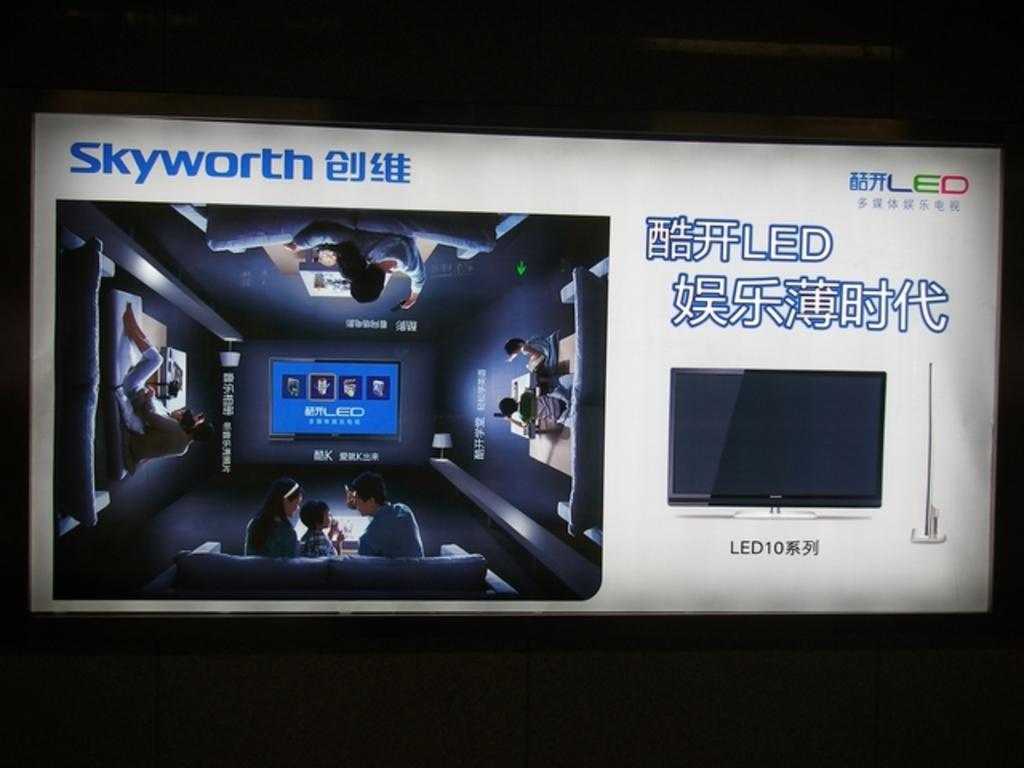What brand of computer is this?
Provide a short and direct response. Skyworth. What does it say on the top right?
Your response must be concise. Led. 